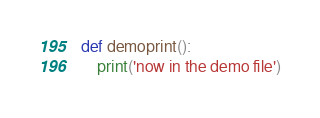<code> <loc_0><loc_0><loc_500><loc_500><_Python_>def demoprint():
    print('now in the demo file')
</code> 